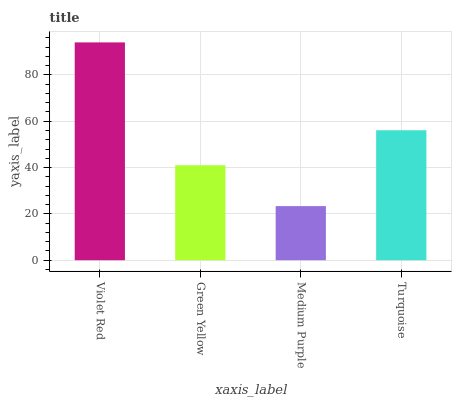Is Medium Purple the minimum?
Answer yes or no. Yes. Is Violet Red the maximum?
Answer yes or no. Yes. Is Green Yellow the minimum?
Answer yes or no. No. Is Green Yellow the maximum?
Answer yes or no. No. Is Violet Red greater than Green Yellow?
Answer yes or no. Yes. Is Green Yellow less than Violet Red?
Answer yes or no. Yes. Is Green Yellow greater than Violet Red?
Answer yes or no. No. Is Violet Red less than Green Yellow?
Answer yes or no. No. Is Turquoise the high median?
Answer yes or no. Yes. Is Green Yellow the low median?
Answer yes or no. Yes. Is Violet Red the high median?
Answer yes or no. No. Is Medium Purple the low median?
Answer yes or no. No. 